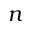Convert formula to latex. <formula><loc_0><loc_0><loc_500><loc_500>n</formula> 